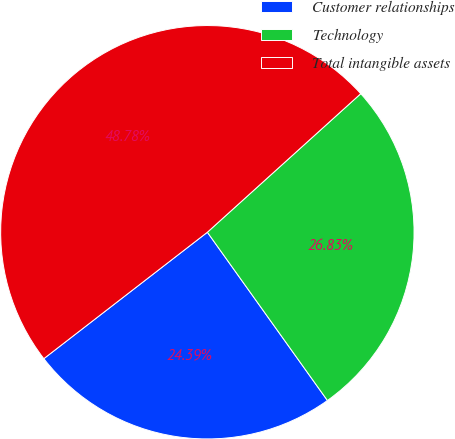Convert chart. <chart><loc_0><loc_0><loc_500><loc_500><pie_chart><fcel>Customer relationships<fcel>Technology<fcel>Total intangible assets<nl><fcel>24.39%<fcel>26.83%<fcel>48.78%<nl></chart> 